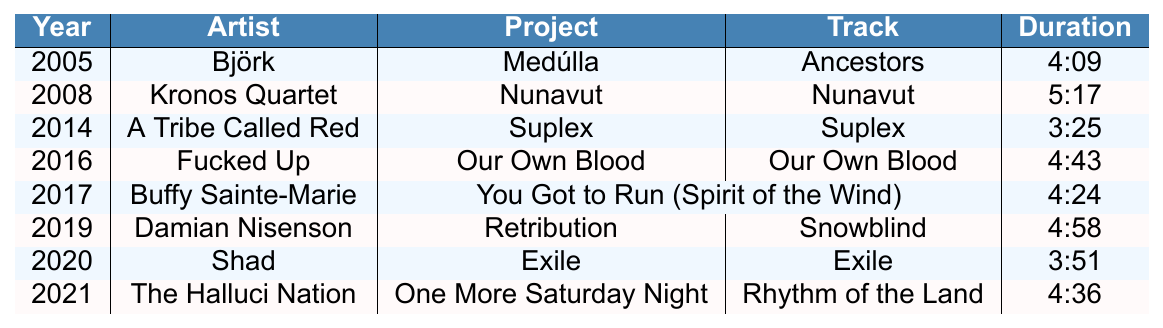What was the duration of the track "Ancestors"? The table shows that the track "Ancestors" is listed under the year 2005 with a duration of 4:09.
Answer: 4:09 Who collaborated with Tanya Tagaq in 2019? According to the table, Tanya Tagaq collaborated with Damian Nisenson in 2019.
Answer: Damian Nisenson Which project features the track "Exile"? The table indicates that the track "Exile" is associated with the project titled "Exile," released in 2020.
Answer: Exile How many collaborations feature tracks longer than 4 minutes? By examining the durations in the table, the collaborations with durations exceeding 4 minutes are "Ancestors," "Nunavut," "Our Own Blood," "You Got to Run," "Snowblind," and "Rhythm of the Land," totaling 6.
Answer: 6 Which artist collaborated with Tanya Tagaq in the earliest year? Reviewing the table, the earliest collaboration is with Björk in 2005.
Answer: Björk Is there a collaboration with Buffy Sainte-Marie in the year 2017? The table confirms that there is indeed a collaboration with Buffy Sainte-Marie listed for the year 2017.
Answer: Yes What is the average duration of the collaborations listed in the table? To find the average, I will sum the durations: 249 + 317 + 205 + 283 + 264 + 298 + 231 + 276 = 2023 seconds. Dividing by the number of collaborations (8) gives an average of 252.875 seconds, which is about 4:13.
Answer: 4:13 Which artist appears in two different projects with Tanya Tagaq? The data shows that Tanya Tagaq collaborates with A Tribe Called Red in 2014 and with Shad in 2020; hence, they appear in separate projects.
Answer: No, none appears in two different projects What is the total duration of all collaborations in minutes? The total duration is 2023 seconds. To convert to minutes, I divide by 60, giving approximately 33.72 minutes (or 33 minutes and 43 seconds).
Answer: 33:43 Which collaboration has the longest duration? Evaluating the durations listed in the table, "Nunavut" with Kronos Quartet has the longest duration of 5:17.
Answer: Nunavut 